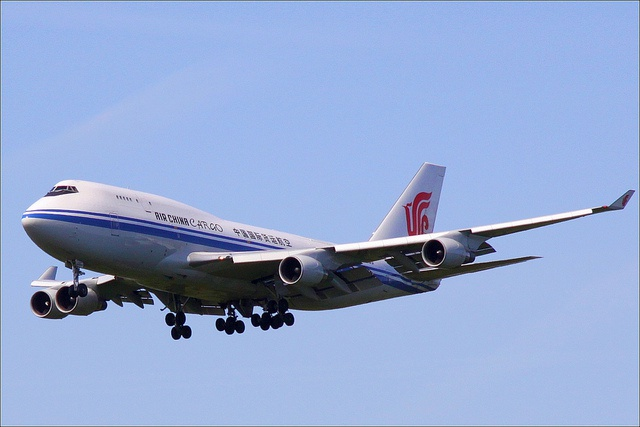Describe the objects in this image and their specific colors. I can see a airplane in gray, black, lavender, darkgray, and navy tones in this image. 